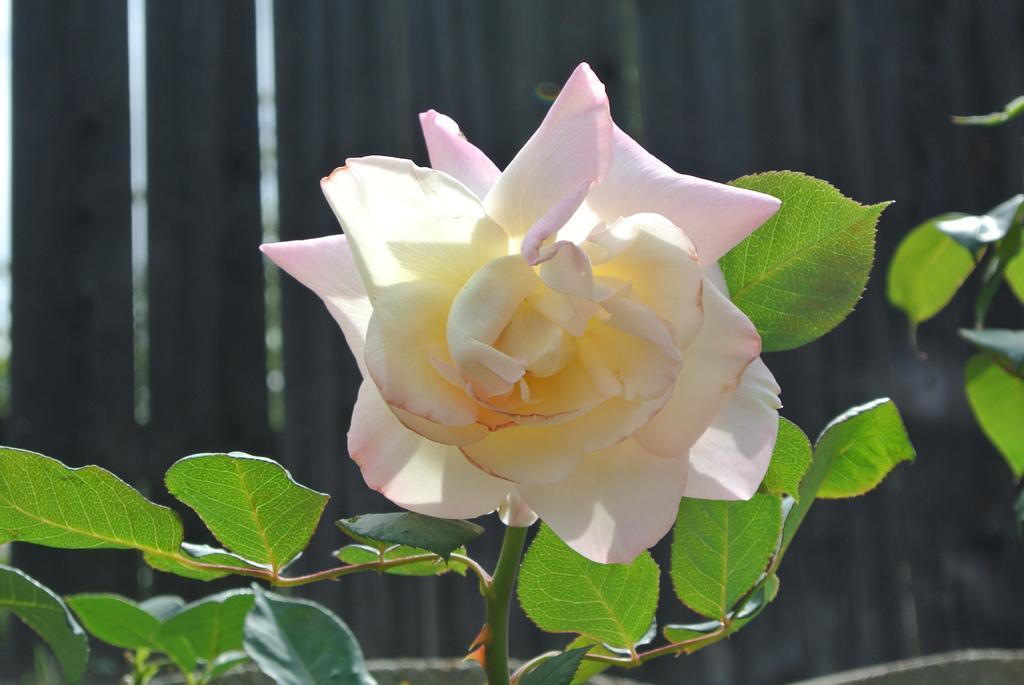How would you summarize this image in a sentence or two? In this picture we can see a plant with a flower. Behind the flower, there is a blurred object. 